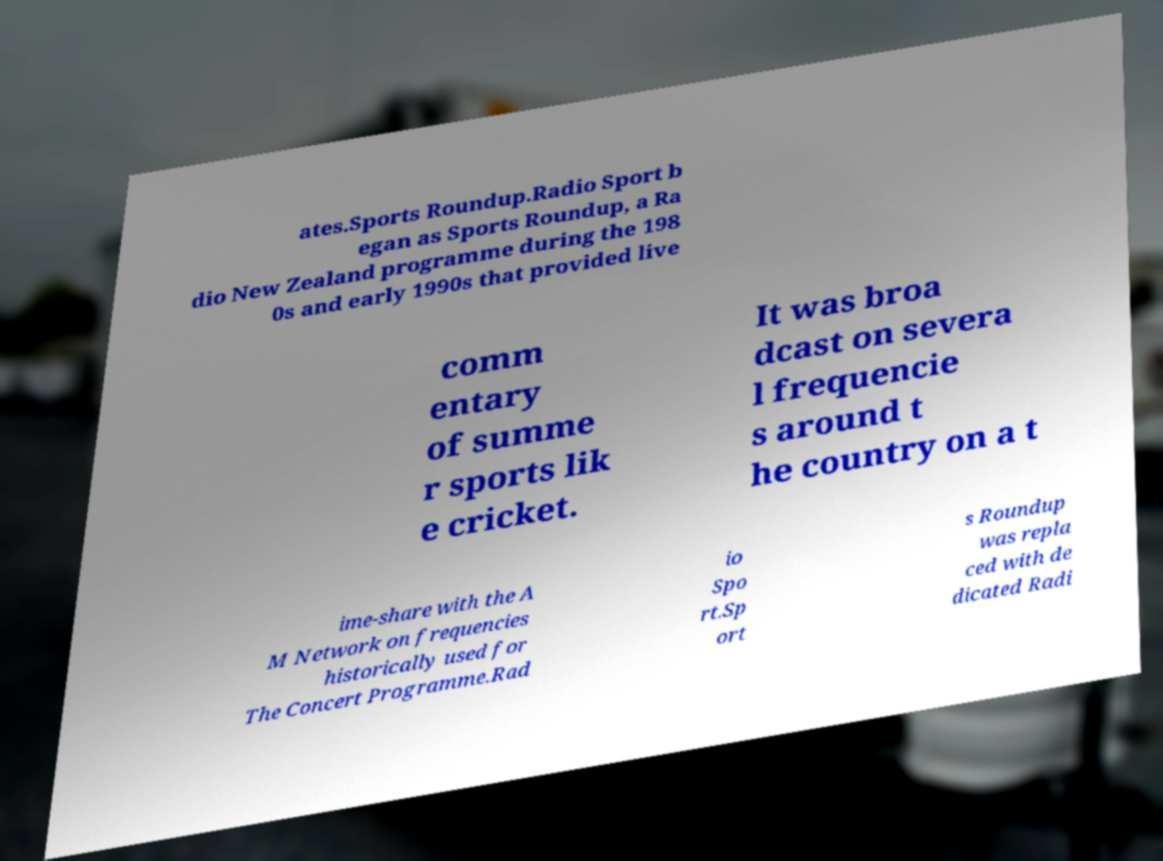What messages or text are displayed in this image? I need them in a readable, typed format. ates.Sports Roundup.Radio Sport b egan as Sports Roundup, a Ra dio New Zealand programme during the 198 0s and early 1990s that provided live comm entary of summe r sports lik e cricket. It was broa dcast on severa l frequencie s around t he country on a t ime-share with the A M Network on frequencies historically used for The Concert Programme.Rad io Spo rt.Sp ort s Roundup was repla ced with de dicated Radi 